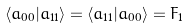Convert formula to latex. <formula><loc_0><loc_0><loc_500><loc_500>\langle a _ { 0 0 } | a _ { 1 1 } \rangle = \langle a _ { 1 1 } | a _ { 0 0 } \rangle = F _ { 1 }</formula> 